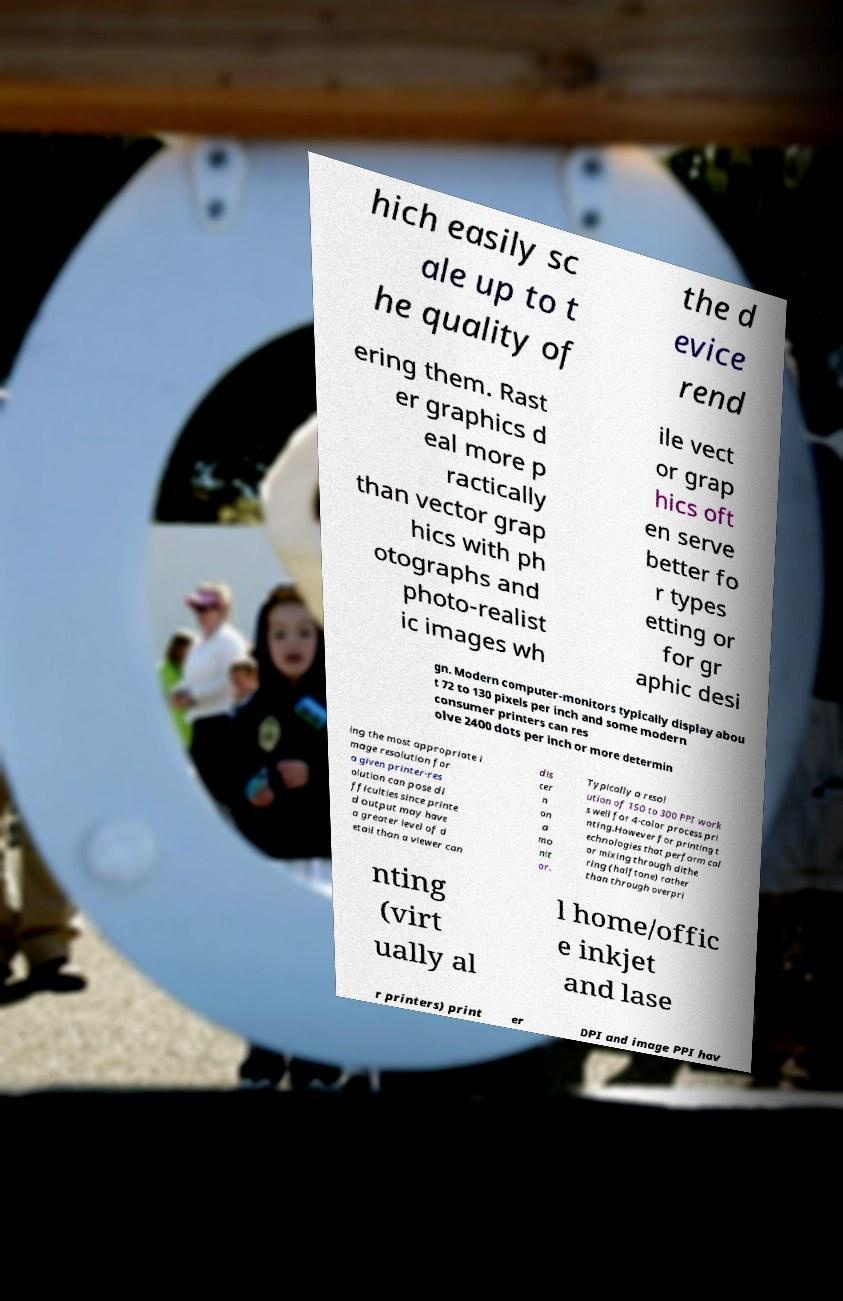Can you accurately transcribe the text from the provided image for me? hich easily sc ale up to t he quality of the d evice rend ering them. Rast er graphics d eal more p ractically than vector grap hics with ph otographs and photo-realist ic images wh ile vect or grap hics oft en serve better fo r types etting or for gr aphic desi gn. Modern computer-monitors typically display abou t 72 to 130 pixels per inch and some modern consumer printers can res olve 2400 dots per inch or more determin ing the most appropriate i mage resolution for a given printer-res olution can pose di fficulties since printe d output may have a greater level of d etail than a viewer can dis cer n on a mo nit or. Typically a resol ution of 150 to 300 PPI work s well for 4-color process pri nting.However for printing t echnologies that perform col or mixing through dithe ring (halftone) rather than through overpri nting (virt ually al l home/offic e inkjet and lase r printers) print er DPI and image PPI hav 